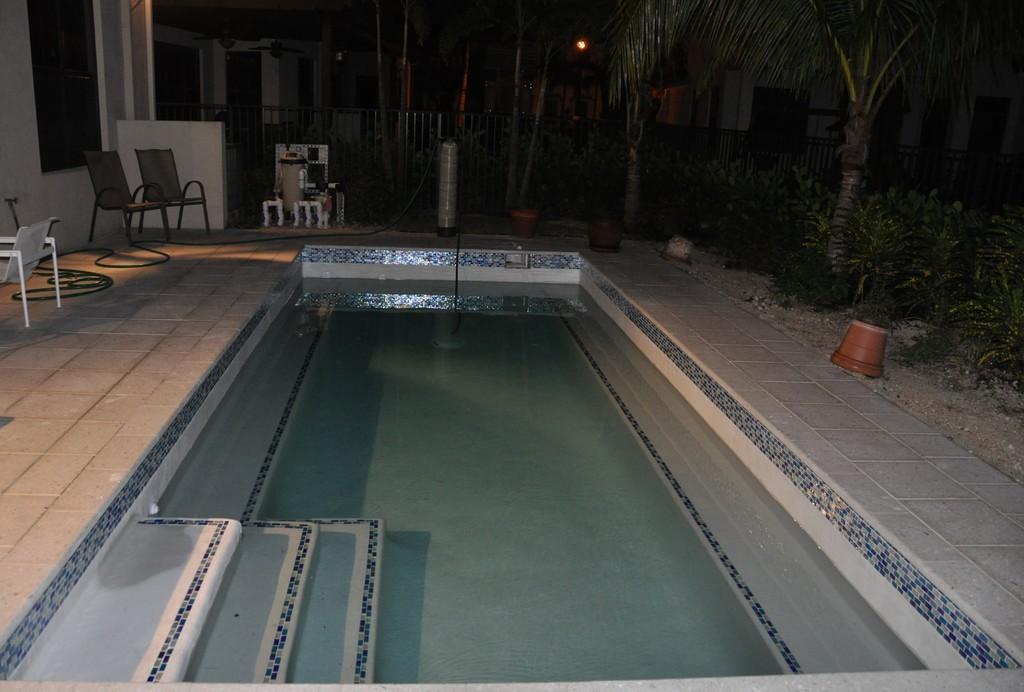In one or two sentences, can you explain what this image depicts? In this picture there are buildings and trees. In the foreground there is a swimming pool and there are chairs and there are objects and flower pots. At the back there is a railing. 